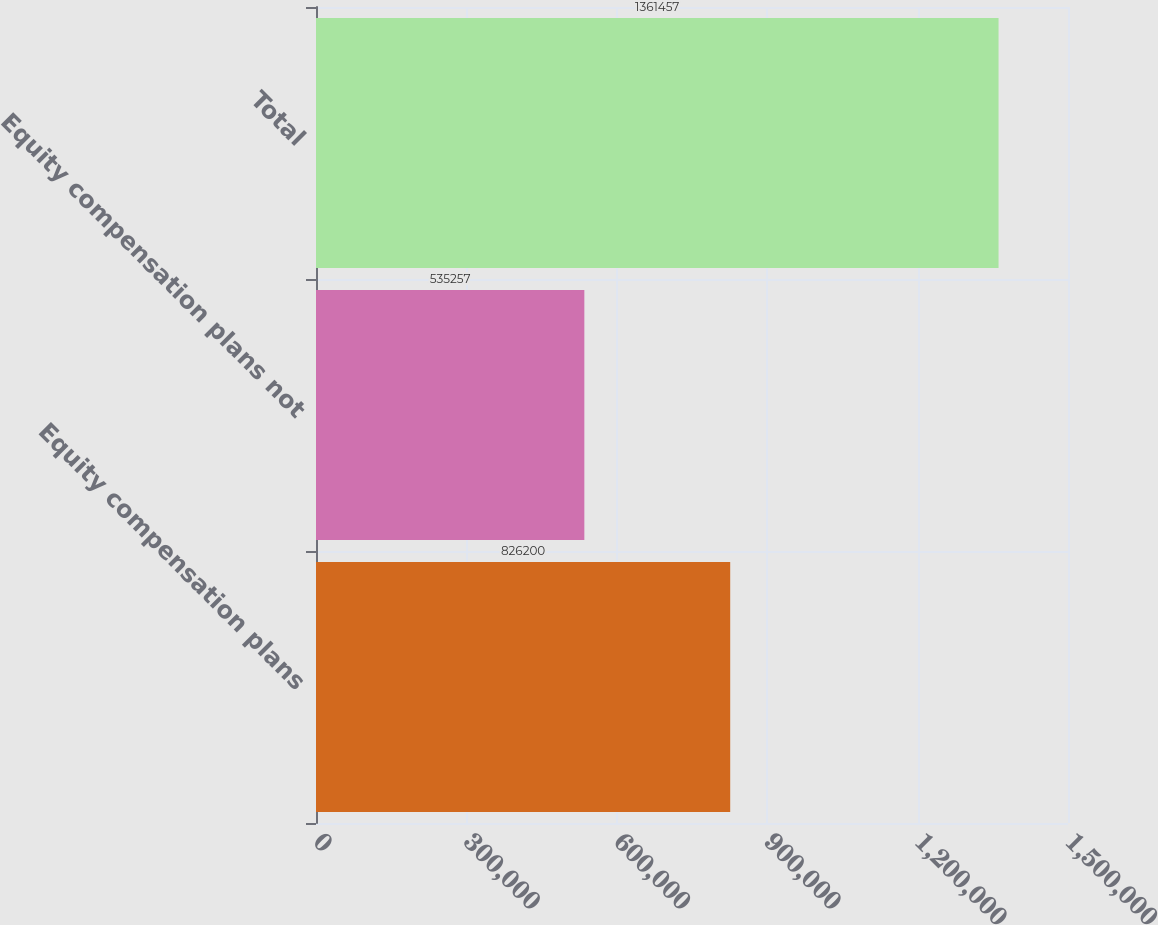Convert chart. <chart><loc_0><loc_0><loc_500><loc_500><bar_chart><fcel>Equity compensation plans<fcel>Equity compensation plans not<fcel>Total<nl><fcel>826200<fcel>535257<fcel>1.36146e+06<nl></chart> 